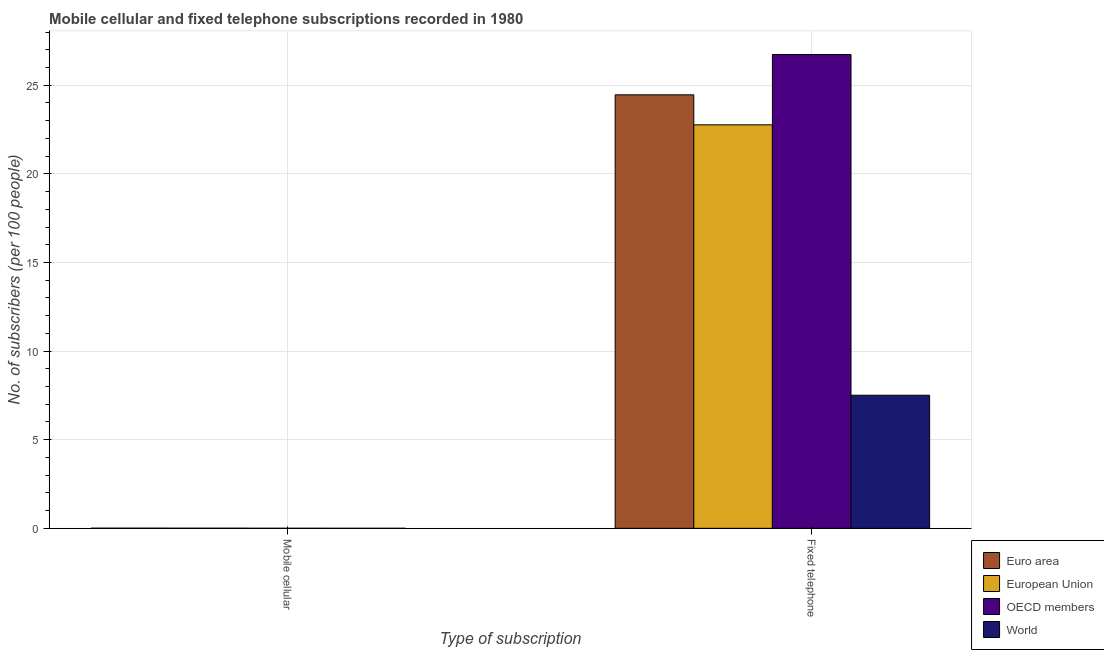How many different coloured bars are there?
Offer a terse response. 4. How many bars are there on the 1st tick from the right?
Give a very brief answer. 4. What is the label of the 1st group of bars from the left?
Your answer should be very brief. Mobile cellular. What is the number of fixed telephone subscribers in Euro area?
Make the answer very short. 24.46. Across all countries, what is the maximum number of fixed telephone subscribers?
Your answer should be very brief. 26.73. Across all countries, what is the minimum number of mobile cellular subscribers?
Keep it short and to the point. 0. In which country was the number of mobile cellular subscribers maximum?
Your response must be concise. Euro area. In which country was the number of mobile cellular subscribers minimum?
Your response must be concise. World. What is the total number of mobile cellular subscribers in the graph?
Keep it short and to the point. 0.02. What is the difference between the number of fixed telephone subscribers in OECD members and that in European Union?
Provide a succinct answer. 3.97. What is the difference between the number of fixed telephone subscribers in OECD members and the number of mobile cellular subscribers in European Union?
Your answer should be very brief. 26.73. What is the average number of fixed telephone subscribers per country?
Offer a very short reply. 20.37. What is the difference between the number of fixed telephone subscribers and number of mobile cellular subscribers in OECD members?
Provide a succinct answer. 26.73. What is the ratio of the number of mobile cellular subscribers in OECD members to that in World?
Give a very brief answer. 4.5. In how many countries, is the number of fixed telephone subscribers greater than the average number of fixed telephone subscribers taken over all countries?
Ensure brevity in your answer.  3. Does the graph contain any zero values?
Ensure brevity in your answer.  No. Where does the legend appear in the graph?
Provide a succinct answer. Bottom right. How many legend labels are there?
Your response must be concise. 4. How are the legend labels stacked?
Make the answer very short. Vertical. What is the title of the graph?
Offer a very short reply. Mobile cellular and fixed telephone subscriptions recorded in 1980. Does "Vietnam" appear as one of the legend labels in the graph?
Provide a short and direct response. No. What is the label or title of the X-axis?
Provide a short and direct response. Type of subscription. What is the label or title of the Y-axis?
Offer a very short reply. No. of subscribers (per 100 people). What is the No. of subscribers (per 100 people) of Euro area in Mobile cellular?
Provide a short and direct response. 0.01. What is the No. of subscribers (per 100 people) in European Union in Mobile cellular?
Your answer should be compact. 0.01. What is the No. of subscribers (per 100 people) in OECD members in Mobile cellular?
Offer a very short reply. 0. What is the No. of subscribers (per 100 people) of World in Mobile cellular?
Provide a succinct answer. 0. What is the No. of subscribers (per 100 people) of Euro area in Fixed telephone?
Ensure brevity in your answer.  24.46. What is the No. of subscribers (per 100 people) in European Union in Fixed telephone?
Your response must be concise. 22.77. What is the No. of subscribers (per 100 people) in OECD members in Fixed telephone?
Offer a terse response. 26.73. What is the No. of subscribers (per 100 people) of World in Fixed telephone?
Provide a short and direct response. 7.51. Across all Type of subscription, what is the maximum No. of subscribers (per 100 people) in Euro area?
Make the answer very short. 24.46. Across all Type of subscription, what is the maximum No. of subscribers (per 100 people) in European Union?
Ensure brevity in your answer.  22.77. Across all Type of subscription, what is the maximum No. of subscribers (per 100 people) of OECD members?
Your answer should be compact. 26.73. Across all Type of subscription, what is the maximum No. of subscribers (per 100 people) in World?
Give a very brief answer. 7.51. Across all Type of subscription, what is the minimum No. of subscribers (per 100 people) of Euro area?
Your answer should be compact. 0.01. Across all Type of subscription, what is the minimum No. of subscribers (per 100 people) in European Union?
Keep it short and to the point. 0.01. Across all Type of subscription, what is the minimum No. of subscribers (per 100 people) of OECD members?
Keep it short and to the point. 0. Across all Type of subscription, what is the minimum No. of subscribers (per 100 people) of World?
Provide a succinct answer. 0. What is the total No. of subscribers (per 100 people) of Euro area in the graph?
Keep it short and to the point. 24.47. What is the total No. of subscribers (per 100 people) of European Union in the graph?
Give a very brief answer. 22.77. What is the total No. of subscribers (per 100 people) of OECD members in the graph?
Provide a succinct answer. 26.74. What is the total No. of subscribers (per 100 people) in World in the graph?
Give a very brief answer. 7.51. What is the difference between the No. of subscribers (per 100 people) in Euro area in Mobile cellular and that in Fixed telephone?
Keep it short and to the point. -24.45. What is the difference between the No. of subscribers (per 100 people) of European Union in Mobile cellular and that in Fixed telephone?
Your answer should be compact. -22.76. What is the difference between the No. of subscribers (per 100 people) of OECD members in Mobile cellular and that in Fixed telephone?
Keep it short and to the point. -26.73. What is the difference between the No. of subscribers (per 100 people) of World in Mobile cellular and that in Fixed telephone?
Offer a very short reply. -7.51. What is the difference between the No. of subscribers (per 100 people) of Euro area in Mobile cellular and the No. of subscribers (per 100 people) of European Union in Fixed telephone?
Offer a very short reply. -22.76. What is the difference between the No. of subscribers (per 100 people) of Euro area in Mobile cellular and the No. of subscribers (per 100 people) of OECD members in Fixed telephone?
Your response must be concise. -26.73. What is the difference between the No. of subscribers (per 100 people) in Euro area in Mobile cellular and the No. of subscribers (per 100 people) in World in Fixed telephone?
Offer a very short reply. -7.5. What is the difference between the No. of subscribers (per 100 people) in European Union in Mobile cellular and the No. of subscribers (per 100 people) in OECD members in Fixed telephone?
Offer a terse response. -26.73. What is the difference between the No. of subscribers (per 100 people) of European Union in Mobile cellular and the No. of subscribers (per 100 people) of World in Fixed telephone?
Keep it short and to the point. -7.5. What is the difference between the No. of subscribers (per 100 people) of OECD members in Mobile cellular and the No. of subscribers (per 100 people) of World in Fixed telephone?
Make the answer very short. -7.51. What is the average No. of subscribers (per 100 people) of Euro area per Type of subscription?
Your answer should be compact. 12.23. What is the average No. of subscribers (per 100 people) in European Union per Type of subscription?
Your answer should be very brief. 11.39. What is the average No. of subscribers (per 100 people) in OECD members per Type of subscription?
Provide a succinct answer. 13.37. What is the average No. of subscribers (per 100 people) in World per Type of subscription?
Provide a short and direct response. 3.75. What is the difference between the No. of subscribers (per 100 people) in Euro area and No. of subscribers (per 100 people) in European Union in Mobile cellular?
Your answer should be very brief. 0. What is the difference between the No. of subscribers (per 100 people) in Euro area and No. of subscribers (per 100 people) in OECD members in Mobile cellular?
Your response must be concise. 0.01. What is the difference between the No. of subscribers (per 100 people) in Euro area and No. of subscribers (per 100 people) in World in Mobile cellular?
Keep it short and to the point. 0.01. What is the difference between the No. of subscribers (per 100 people) in European Union and No. of subscribers (per 100 people) in OECD members in Mobile cellular?
Offer a terse response. 0. What is the difference between the No. of subscribers (per 100 people) in European Union and No. of subscribers (per 100 people) in World in Mobile cellular?
Keep it short and to the point. 0. What is the difference between the No. of subscribers (per 100 people) of OECD members and No. of subscribers (per 100 people) of World in Mobile cellular?
Your answer should be compact. 0. What is the difference between the No. of subscribers (per 100 people) in Euro area and No. of subscribers (per 100 people) in European Union in Fixed telephone?
Provide a short and direct response. 1.69. What is the difference between the No. of subscribers (per 100 people) of Euro area and No. of subscribers (per 100 people) of OECD members in Fixed telephone?
Your answer should be compact. -2.27. What is the difference between the No. of subscribers (per 100 people) in Euro area and No. of subscribers (per 100 people) in World in Fixed telephone?
Offer a terse response. 16.95. What is the difference between the No. of subscribers (per 100 people) of European Union and No. of subscribers (per 100 people) of OECD members in Fixed telephone?
Your answer should be very brief. -3.97. What is the difference between the No. of subscribers (per 100 people) in European Union and No. of subscribers (per 100 people) in World in Fixed telephone?
Your response must be concise. 15.26. What is the difference between the No. of subscribers (per 100 people) in OECD members and No. of subscribers (per 100 people) in World in Fixed telephone?
Make the answer very short. 19.22. What is the ratio of the No. of subscribers (per 100 people) of Euro area in Mobile cellular to that in Fixed telephone?
Keep it short and to the point. 0. What is the ratio of the No. of subscribers (per 100 people) in OECD members in Mobile cellular to that in Fixed telephone?
Your answer should be very brief. 0. What is the difference between the highest and the second highest No. of subscribers (per 100 people) in Euro area?
Give a very brief answer. 24.45. What is the difference between the highest and the second highest No. of subscribers (per 100 people) in European Union?
Offer a very short reply. 22.76. What is the difference between the highest and the second highest No. of subscribers (per 100 people) in OECD members?
Give a very brief answer. 26.73. What is the difference between the highest and the second highest No. of subscribers (per 100 people) in World?
Keep it short and to the point. 7.51. What is the difference between the highest and the lowest No. of subscribers (per 100 people) of Euro area?
Make the answer very short. 24.45. What is the difference between the highest and the lowest No. of subscribers (per 100 people) of European Union?
Provide a short and direct response. 22.76. What is the difference between the highest and the lowest No. of subscribers (per 100 people) in OECD members?
Offer a terse response. 26.73. What is the difference between the highest and the lowest No. of subscribers (per 100 people) in World?
Your answer should be very brief. 7.51. 